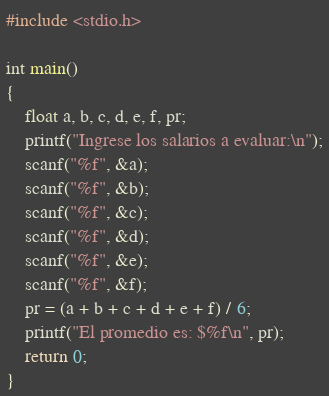Convert code to text. <code><loc_0><loc_0><loc_500><loc_500><_C_>#include <stdio.h>

int main()
{
	float a, b, c, d, e, f, pr;
	printf("Ingrese los salarios a evaluar:\n");
	scanf("%f", &a);
	scanf("%f", &b);
	scanf("%f", &c);
	scanf("%f", &d);
	scanf("%f", &e);
	scanf("%f", &f);
	pr = (a + b + c + d + e + f) / 6;
	printf("El promedio es: $%f\n", pr);
	return 0;
}</code> 